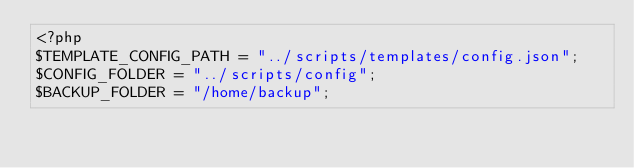Convert code to text. <code><loc_0><loc_0><loc_500><loc_500><_PHP_><?php
$TEMPLATE_CONFIG_PATH = "../scripts/templates/config.json";
$CONFIG_FOLDER = "../scripts/config";
$BACKUP_FOLDER = "/home/backup";
</code> 